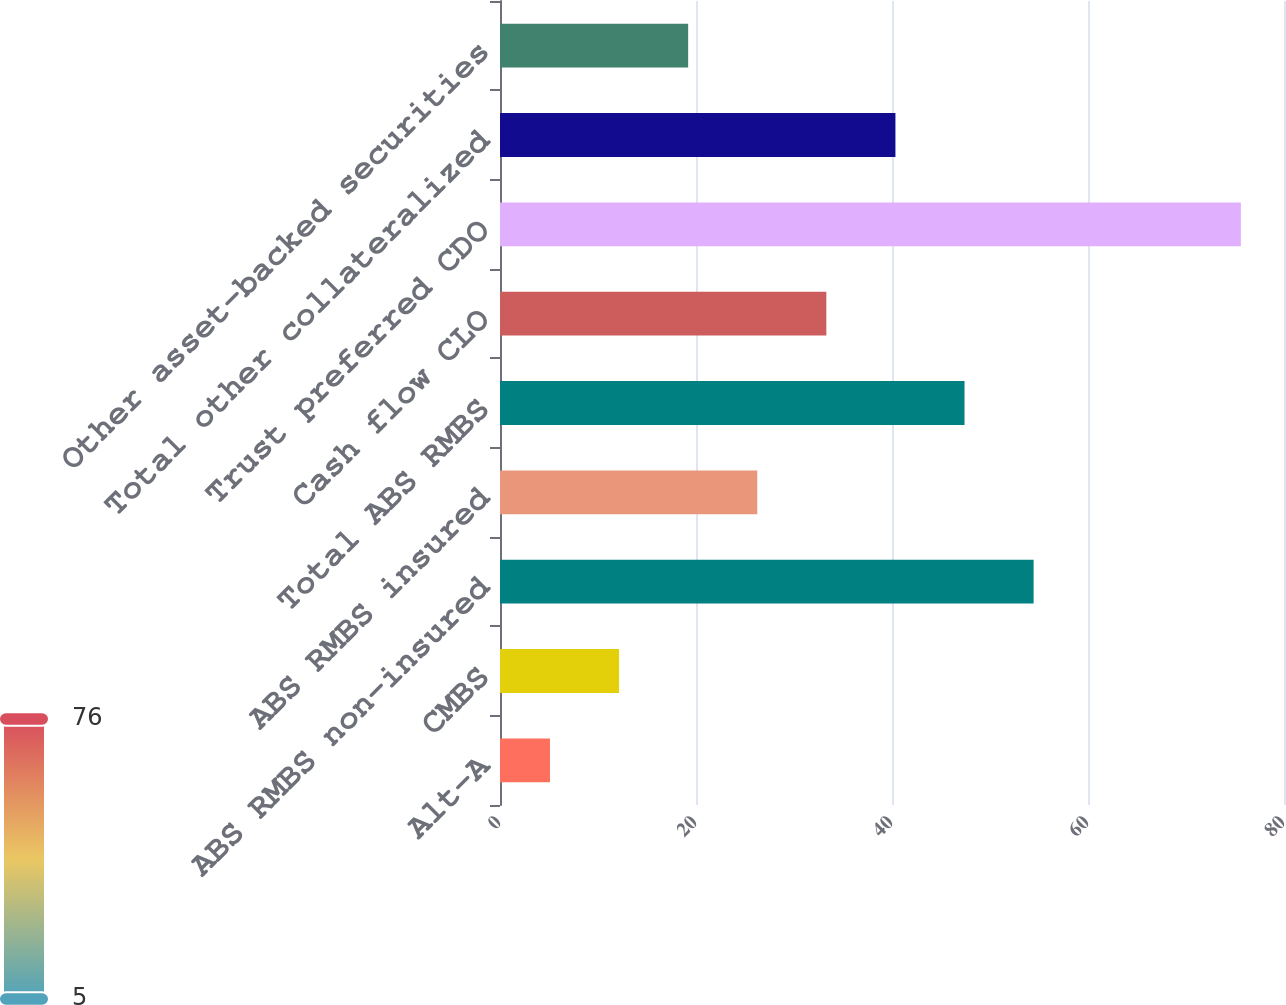Convert chart. <chart><loc_0><loc_0><loc_500><loc_500><bar_chart><fcel>Alt-A<fcel>CMBS<fcel>ABS RMBS non-insured<fcel>ABS RMBS insured<fcel>Total ABS RMBS<fcel>Cash flow CLO<fcel>Trust preferred CDO<fcel>Total other collateralized<fcel>Other asset-backed securities<nl><fcel>5.1<fcel>12.15<fcel>54.45<fcel>26.25<fcel>47.4<fcel>33.3<fcel>75.6<fcel>40.35<fcel>19.2<nl></chart> 